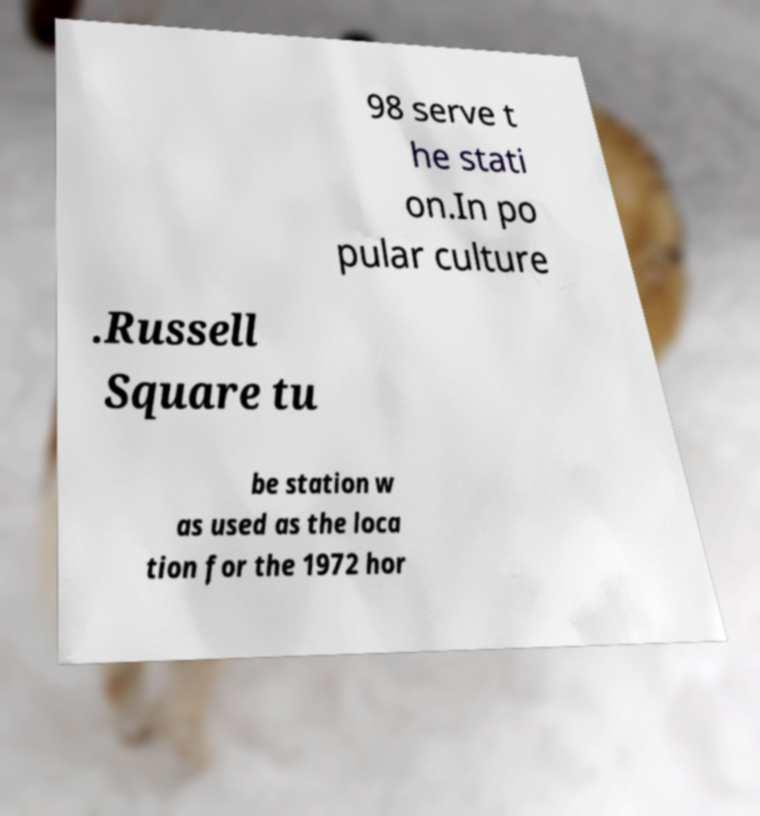Can you accurately transcribe the text from the provided image for me? 98 serve t he stati on.In po pular culture .Russell Square tu be station w as used as the loca tion for the 1972 hor 